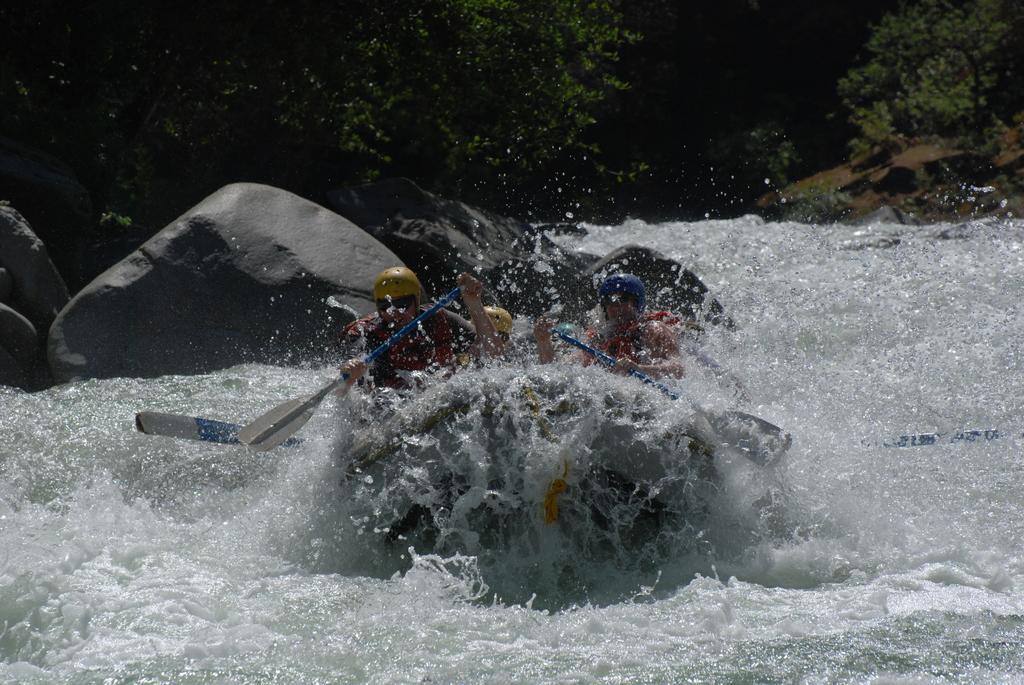Can you describe this image briefly? In this picture I can see a boat which is on the water and on the boat I can see few persons holding paddles. In the background I can see the rocks and the trees. 